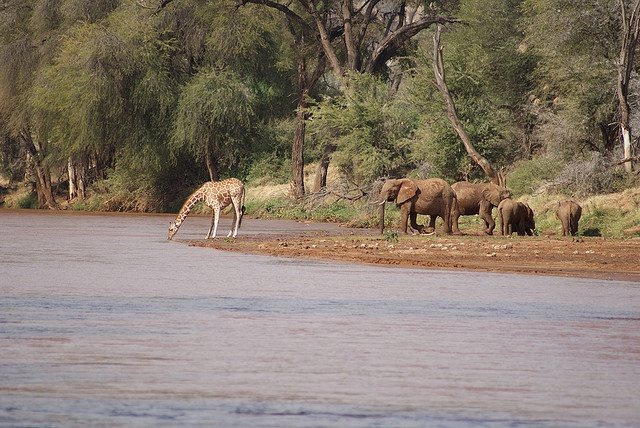Describe the objects in this image and their specific colors. I can see elephant in gray, black, maroon, and tan tones, giraffe in gray, tan, and beige tones, elephant in gray, tan, brown, and black tones, elephant in gray, black, tan, and brown tones, and elephant in gray, black, tan, and brown tones in this image. 